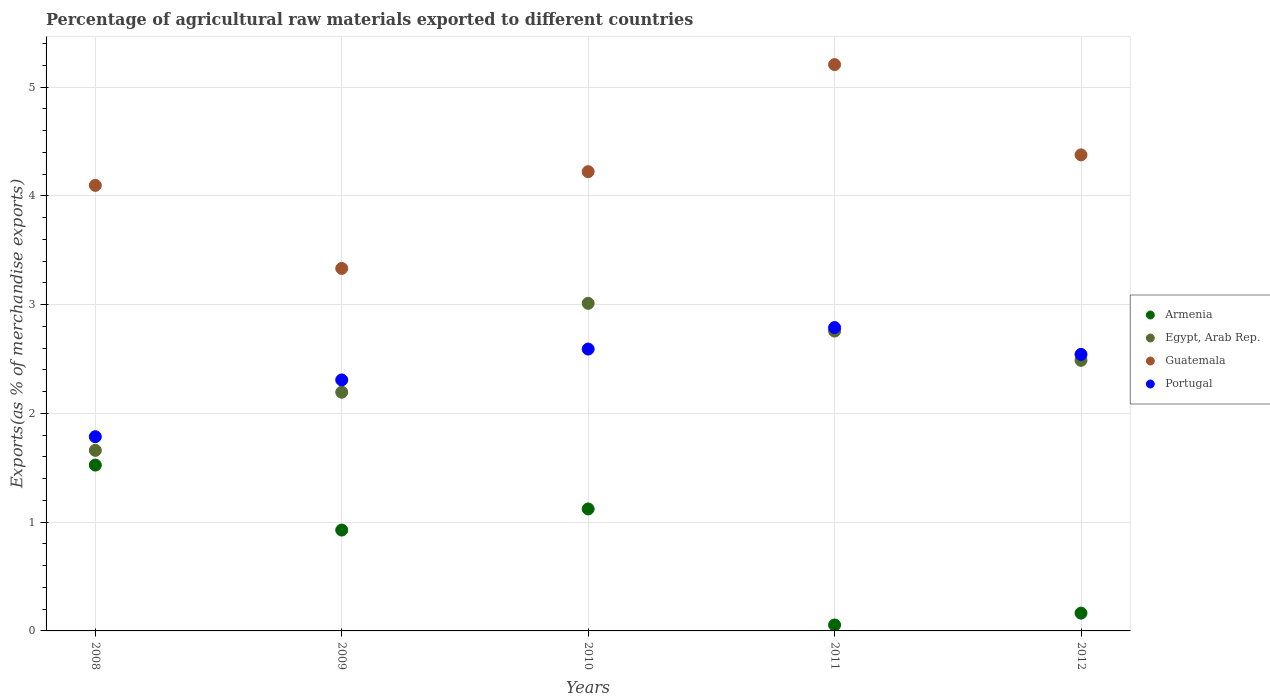Is the number of dotlines equal to the number of legend labels?
Your answer should be compact. Yes. What is the percentage of exports to different countries in Armenia in 2008?
Give a very brief answer. 1.52. Across all years, what is the maximum percentage of exports to different countries in Portugal?
Your answer should be very brief. 2.79. Across all years, what is the minimum percentage of exports to different countries in Egypt, Arab Rep.?
Provide a succinct answer. 1.66. In which year was the percentage of exports to different countries in Egypt, Arab Rep. minimum?
Offer a terse response. 2008. What is the total percentage of exports to different countries in Egypt, Arab Rep. in the graph?
Offer a very short reply. 12.11. What is the difference between the percentage of exports to different countries in Egypt, Arab Rep. in 2008 and that in 2010?
Keep it short and to the point. -1.35. What is the difference between the percentage of exports to different countries in Armenia in 2009 and the percentage of exports to different countries in Guatemala in 2012?
Provide a short and direct response. -3.45. What is the average percentage of exports to different countries in Armenia per year?
Make the answer very short. 0.76. In the year 2008, what is the difference between the percentage of exports to different countries in Armenia and percentage of exports to different countries in Guatemala?
Your answer should be very brief. -2.57. In how many years, is the percentage of exports to different countries in Portugal greater than 1 %?
Ensure brevity in your answer.  5. What is the ratio of the percentage of exports to different countries in Armenia in 2010 to that in 2012?
Your answer should be compact. 6.85. Is the difference between the percentage of exports to different countries in Armenia in 2011 and 2012 greater than the difference between the percentage of exports to different countries in Guatemala in 2011 and 2012?
Provide a succinct answer. No. What is the difference between the highest and the second highest percentage of exports to different countries in Armenia?
Offer a terse response. 0.4. What is the difference between the highest and the lowest percentage of exports to different countries in Egypt, Arab Rep.?
Keep it short and to the point. 1.35. Is it the case that in every year, the sum of the percentage of exports to different countries in Guatemala and percentage of exports to different countries in Egypt, Arab Rep.  is greater than the sum of percentage of exports to different countries in Armenia and percentage of exports to different countries in Portugal?
Ensure brevity in your answer.  No. Does the percentage of exports to different countries in Guatemala monotonically increase over the years?
Provide a succinct answer. No. How many years are there in the graph?
Ensure brevity in your answer.  5. What is the difference between two consecutive major ticks on the Y-axis?
Give a very brief answer. 1. Are the values on the major ticks of Y-axis written in scientific E-notation?
Your response must be concise. No. Where does the legend appear in the graph?
Your answer should be very brief. Center right. What is the title of the graph?
Provide a succinct answer. Percentage of agricultural raw materials exported to different countries. Does "Iran" appear as one of the legend labels in the graph?
Make the answer very short. No. What is the label or title of the Y-axis?
Provide a succinct answer. Exports(as % of merchandise exports). What is the Exports(as % of merchandise exports) of Armenia in 2008?
Keep it short and to the point. 1.52. What is the Exports(as % of merchandise exports) of Egypt, Arab Rep. in 2008?
Ensure brevity in your answer.  1.66. What is the Exports(as % of merchandise exports) in Guatemala in 2008?
Keep it short and to the point. 4.1. What is the Exports(as % of merchandise exports) of Portugal in 2008?
Make the answer very short. 1.79. What is the Exports(as % of merchandise exports) of Armenia in 2009?
Your answer should be very brief. 0.93. What is the Exports(as % of merchandise exports) in Egypt, Arab Rep. in 2009?
Keep it short and to the point. 2.19. What is the Exports(as % of merchandise exports) in Guatemala in 2009?
Offer a terse response. 3.33. What is the Exports(as % of merchandise exports) of Portugal in 2009?
Offer a very short reply. 2.31. What is the Exports(as % of merchandise exports) in Armenia in 2010?
Provide a short and direct response. 1.12. What is the Exports(as % of merchandise exports) in Egypt, Arab Rep. in 2010?
Provide a succinct answer. 3.01. What is the Exports(as % of merchandise exports) of Guatemala in 2010?
Offer a very short reply. 4.22. What is the Exports(as % of merchandise exports) of Portugal in 2010?
Your answer should be very brief. 2.59. What is the Exports(as % of merchandise exports) in Armenia in 2011?
Your response must be concise. 0.05. What is the Exports(as % of merchandise exports) of Egypt, Arab Rep. in 2011?
Your answer should be compact. 2.76. What is the Exports(as % of merchandise exports) of Guatemala in 2011?
Ensure brevity in your answer.  5.21. What is the Exports(as % of merchandise exports) of Portugal in 2011?
Your response must be concise. 2.79. What is the Exports(as % of merchandise exports) in Armenia in 2012?
Your answer should be very brief. 0.16. What is the Exports(as % of merchandise exports) in Egypt, Arab Rep. in 2012?
Keep it short and to the point. 2.49. What is the Exports(as % of merchandise exports) of Guatemala in 2012?
Provide a short and direct response. 4.38. What is the Exports(as % of merchandise exports) in Portugal in 2012?
Your response must be concise. 2.54. Across all years, what is the maximum Exports(as % of merchandise exports) in Armenia?
Offer a terse response. 1.52. Across all years, what is the maximum Exports(as % of merchandise exports) in Egypt, Arab Rep.?
Your answer should be compact. 3.01. Across all years, what is the maximum Exports(as % of merchandise exports) of Guatemala?
Ensure brevity in your answer.  5.21. Across all years, what is the maximum Exports(as % of merchandise exports) of Portugal?
Your answer should be very brief. 2.79. Across all years, what is the minimum Exports(as % of merchandise exports) of Armenia?
Provide a short and direct response. 0.05. Across all years, what is the minimum Exports(as % of merchandise exports) of Egypt, Arab Rep.?
Provide a succinct answer. 1.66. Across all years, what is the minimum Exports(as % of merchandise exports) of Guatemala?
Provide a short and direct response. 3.33. Across all years, what is the minimum Exports(as % of merchandise exports) of Portugal?
Offer a very short reply. 1.79. What is the total Exports(as % of merchandise exports) in Armenia in the graph?
Give a very brief answer. 3.79. What is the total Exports(as % of merchandise exports) of Egypt, Arab Rep. in the graph?
Give a very brief answer. 12.11. What is the total Exports(as % of merchandise exports) of Guatemala in the graph?
Provide a succinct answer. 21.23. What is the total Exports(as % of merchandise exports) in Portugal in the graph?
Provide a short and direct response. 12.02. What is the difference between the Exports(as % of merchandise exports) in Armenia in 2008 and that in 2009?
Provide a short and direct response. 0.6. What is the difference between the Exports(as % of merchandise exports) of Egypt, Arab Rep. in 2008 and that in 2009?
Your answer should be very brief. -0.53. What is the difference between the Exports(as % of merchandise exports) of Guatemala in 2008 and that in 2009?
Provide a succinct answer. 0.76. What is the difference between the Exports(as % of merchandise exports) of Portugal in 2008 and that in 2009?
Provide a short and direct response. -0.52. What is the difference between the Exports(as % of merchandise exports) of Armenia in 2008 and that in 2010?
Give a very brief answer. 0.4. What is the difference between the Exports(as % of merchandise exports) in Egypt, Arab Rep. in 2008 and that in 2010?
Offer a terse response. -1.35. What is the difference between the Exports(as % of merchandise exports) of Guatemala in 2008 and that in 2010?
Make the answer very short. -0.13. What is the difference between the Exports(as % of merchandise exports) of Portugal in 2008 and that in 2010?
Offer a terse response. -0.81. What is the difference between the Exports(as % of merchandise exports) in Armenia in 2008 and that in 2011?
Provide a short and direct response. 1.47. What is the difference between the Exports(as % of merchandise exports) of Egypt, Arab Rep. in 2008 and that in 2011?
Offer a terse response. -1.1. What is the difference between the Exports(as % of merchandise exports) in Guatemala in 2008 and that in 2011?
Provide a short and direct response. -1.11. What is the difference between the Exports(as % of merchandise exports) of Portugal in 2008 and that in 2011?
Your response must be concise. -1. What is the difference between the Exports(as % of merchandise exports) of Armenia in 2008 and that in 2012?
Your response must be concise. 1.36. What is the difference between the Exports(as % of merchandise exports) in Egypt, Arab Rep. in 2008 and that in 2012?
Give a very brief answer. -0.83. What is the difference between the Exports(as % of merchandise exports) of Guatemala in 2008 and that in 2012?
Give a very brief answer. -0.28. What is the difference between the Exports(as % of merchandise exports) of Portugal in 2008 and that in 2012?
Make the answer very short. -0.76. What is the difference between the Exports(as % of merchandise exports) of Armenia in 2009 and that in 2010?
Provide a succinct answer. -0.19. What is the difference between the Exports(as % of merchandise exports) in Egypt, Arab Rep. in 2009 and that in 2010?
Offer a terse response. -0.82. What is the difference between the Exports(as % of merchandise exports) of Guatemala in 2009 and that in 2010?
Provide a short and direct response. -0.89. What is the difference between the Exports(as % of merchandise exports) of Portugal in 2009 and that in 2010?
Offer a terse response. -0.28. What is the difference between the Exports(as % of merchandise exports) in Armenia in 2009 and that in 2011?
Give a very brief answer. 0.87. What is the difference between the Exports(as % of merchandise exports) in Egypt, Arab Rep. in 2009 and that in 2011?
Provide a short and direct response. -0.56. What is the difference between the Exports(as % of merchandise exports) of Guatemala in 2009 and that in 2011?
Your answer should be very brief. -1.87. What is the difference between the Exports(as % of merchandise exports) in Portugal in 2009 and that in 2011?
Provide a short and direct response. -0.48. What is the difference between the Exports(as % of merchandise exports) in Armenia in 2009 and that in 2012?
Your response must be concise. 0.76. What is the difference between the Exports(as % of merchandise exports) in Egypt, Arab Rep. in 2009 and that in 2012?
Your answer should be very brief. -0.29. What is the difference between the Exports(as % of merchandise exports) of Guatemala in 2009 and that in 2012?
Offer a very short reply. -1.04. What is the difference between the Exports(as % of merchandise exports) of Portugal in 2009 and that in 2012?
Make the answer very short. -0.23. What is the difference between the Exports(as % of merchandise exports) of Armenia in 2010 and that in 2011?
Offer a terse response. 1.07. What is the difference between the Exports(as % of merchandise exports) of Egypt, Arab Rep. in 2010 and that in 2011?
Give a very brief answer. 0.26. What is the difference between the Exports(as % of merchandise exports) in Guatemala in 2010 and that in 2011?
Provide a succinct answer. -0.98. What is the difference between the Exports(as % of merchandise exports) of Portugal in 2010 and that in 2011?
Your answer should be very brief. -0.2. What is the difference between the Exports(as % of merchandise exports) of Armenia in 2010 and that in 2012?
Keep it short and to the point. 0.96. What is the difference between the Exports(as % of merchandise exports) of Egypt, Arab Rep. in 2010 and that in 2012?
Your answer should be very brief. 0.52. What is the difference between the Exports(as % of merchandise exports) of Guatemala in 2010 and that in 2012?
Offer a terse response. -0.15. What is the difference between the Exports(as % of merchandise exports) of Portugal in 2010 and that in 2012?
Provide a succinct answer. 0.05. What is the difference between the Exports(as % of merchandise exports) of Armenia in 2011 and that in 2012?
Give a very brief answer. -0.11. What is the difference between the Exports(as % of merchandise exports) of Egypt, Arab Rep. in 2011 and that in 2012?
Offer a terse response. 0.27. What is the difference between the Exports(as % of merchandise exports) in Guatemala in 2011 and that in 2012?
Keep it short and to the point. 0.83. What is the difference between the Exports(as % of merchandise exports) of Portugal in 2011 and that in 2012?
Make the answer very short. 0.25. What is the difference between the Exports(as % of merchandise exports) of Armenia in 2008 and the Exports(as % of merchandise exports) of Egypt, Arab Rep. in 2009?
Your answer should be compact. -0.67. What is the difference between the Exports(as % of merchandise exports) in Armenia in 2008 and the Exports(as % of merchandise exports) in Guatemala in 2009?
Provide a short and direct response. -1.81. What is the difference between the Exports(as % of merchandise exports) of Armenia in 2008 and the Exports(as % of merchandise exports) of Portugal in 2009?
Give a very brief answer. -0.78. What is the difference between the Exports(as % of merchandise exports) of Egypt, Arab Rep. in 2008 and the Exports(as % of merchandise exports) of Guatemala in 2009?
Ensure brevity in your answer.  -1.67. What is the difference between the Exports(as % of merchandise exports) in Egypt, Arab Rep. in 2008 and the Exports(as % of merchandise exports) in Portugal in 2009?
Ensure brevity in your answer.  -0.65. What is the difference between the Exports(as % of merchandise exports) in Guatemala in 2008 and the Exports(as % of merchandise exports) in Portugal in 2009?
Offer a very short reply. 1.79. What is the difference between the Exports(as % of merchandise exports) in Armenia in 2008 and the Exports(as % of merchandise exports) in Egypt, Arab Rep. in 2010?
Give a very brief answer. -1.49. What is the difference between the Exports(as % of merchandise exports) of Armenia in 2008 and the Exports(as % of merchandise exports) of Guatemala in 2010?
Offer a very short reply. -2.7. What is the difference between the Exports(as % of merchandise exports) in Armenia in 2008 and the Exports(as % of merchandise exports) in Portugal in 2010?
Your answer should be very brief. -1.07. What is the difference between the Exports(as % of merchandise exports) of Egypt, Arab Rep. in 2008 and the Exports(as % of merchandise exports) of Guatemala in 2010?
Your answer should be very brief. -2.56. What is the difference between the Exports(as % of merchandise exports) in Egypt, Arab Rep. in 2008 and the Exports(as % of merchandise exports) in Portugal in 2010?
Make the answer very short. -0.93. What is the difference between the Exports(as % of merchandise exports) in Guatemala in 2008 and the Exports(as % of merchandise exports) in Portugal in 2010?
Provide a short and direct response. 1.5. What is the difference between the Exports(as % of merchandise exports) in Armenia in 2008 and the Exports(as % of merchandise exports) in Egypt, Arab Rep. in 2011?
Your answer should be very brief. -1.23. What is the difference between the Exports(as % of merchandise exports) in Armenia in 2008 and the Exports(as % of merchandise exports) in Guatemala in 2011?
Provide a succinct answer. -3.68. What is the difference between the Exports(as % of merchandise exports) in Armenia in 2008 and the Exports(as % of merchandise exports) in Portugal in 2011?
Your answer should be compact. -1.26. What is the difference between the Exports(as % of merchandise exports) of Egypt, Arab Rep. in 2008 and the Exports(as % of merchandise exports) of Guatemala in 2011?
Keep it short and to the point. -3.55. What is the difference between the Exports(as % of merchandise exports) in Egypt, Arab Rep. in 2008 and the Exports(as % of merchandise exports) in Portugal in 2011?
Provide a succinct answer. -1.13. What is the difference between the Exports(as % of merchandise exports) in Guatemala in 2008 and the Exports(as % of merchandise exports) in Portugal in 2011?
Ensure brevity in your answer.  1.31. What is the difference between the Exports(as % of merchandise exports) in Armenia in 2008 and the Exports(as % of merchandise exports) in Egypt, Arab Rep. in 2012?
Ensure brevity in your answer.  -0.96. What is the difference between the Exports(as % of merchandise exports) in Armenia in 2008 and the Exports(as % of merchandise exports) in Guatemala in 2012?
Your answer should be compact. -2.85. What is the difference between the Exports(as % of merchandise exports) in Armenia in 2008 and the Exports(as % of merchandise exports) in Portugal in 2012?
Provide a short and direct response. -1.02. What is the difference between the Exports(as % of merchandise exports) of Egypt, Arab Rep. in 2008 and the Exports(as % of merchandise exports) of Guatemala in 2012?
Your answer should be very brief. -2.72. What is the difference between the Exports(as % of merchandise exports) of Egypt, Arab Rep. in 2008 and the Exports(as % of merchandise exports) of Portugal in 2012?
Make the answer very short. -0.88. What is the difference between the Exports(as % of merchandise exports) of Guatemala in 2008 and the Exports(as % of merchandise exports) of Portugal in 2012?
Make the answer very short. 1.55. What is the difference between the Exports(as % of merchandise exports) of Armenia in 2009 and the Exports(as % of merchandise exports) of Egypt, Arab Rep. in 2010?
Offer a very short reply. -2.08. What is the difference between the Exports(as % of merchandise exports) in Armenia in 2009 and the Exports(as % of merchandise exports) in Guatemala in 2010?
Provide a short and direct response. -3.3. What is the difference between the Exports(as % of merchandise exports) in Armenia in 2009 and the Exports(as % of merchandise exports) in Portugal in 2010?
Offer a very short reply. -1.66. What is the difference between the Exports(as % of merchandise exports) of Egypt, Arab Rep. in 2009 and the Exports(as % of merchandise exports) of Guatemala in 2010?
Your answer should be compact. -2.03. What is the difference between the Exports(as % of merchandise exports) of Egypt, Arab Rep. in 2009 and the Exports(as % of merchandise exports) of Portugal in 2010?
Keep it short and to the point. -0.4. What is the difference between the Exports(as % of merchandise exports) of Guatemala in 2009 and the Exports(as % of merchandise exports) of Portugal in 2010?
Provide a succinct answer. 0.74. What is the difference between the Exports(as % of merchandise exports) of Armenia in 2009 and the Exports(as % of merchandise exports) of Egypt, Arab Rep. in 2011?
Make the answer very short. -1.83. What is the difference between the Exports(as % of merchandise exports) in Armenia in 2009 and the Exports(as % of merchandise exports) in Guatemala in 2011?
Your answer should be very brief. -4.28. What is the difference between the Exports(as % of merchandise exports) of Armenia in 2009 and the Exports(as % of merchandise exports) of Portugal in 2011?
Ensure brevity in your answer.  -1.86. What is the difference between the Exports(as % of merchandise exports) in Egypt, Arab Rep. in 2009 and the Exports(as % of merchandise exports) in Guatemala in 2011?
Your answer should be very brief. -3.01. What is the difference between the Exports(as % of merchandise exports) of Egypt, Arab Rep. in 2009 and the Exports(as % of merchandise exports) of Portugal in 2011?
Your answer should be compact. -0.59. What is the difference between the Exports(as % of merchandise exports) of Guatemala in 2009 and the Exports(as % of merchandise exports) of Portugal in 2011?
Offer a very short reply. 0.54. What is the difference between the Exports(as % of merchandise exports) of Armenia in 2009 and the Exports(as % of merchandise exports) of Egypt, Arab Rep. in 2012?
Offer a very short reply. -1.56. What is the difference between the Exports(as % of merchandise exports) of Armenia in 2009 and the Exports(as % of merchandise exports) of Guatemala in 2012?
Ensure brevity in your answer.  -3.45. What is the difference between the Exports(as % of merchandise exports) in Armenia in 2009 and the Exports(as % of merchandise exports) in Portugal in 2012?
Your answer should be very brief. -1.61. What is the difference between the Exports(as % of merchandise exports) of Egypt, Arab Rep. in 2009 and the Exports(as % of merchandise exports) of Guatemala in 2012?
Ensure brevity in your answer.  -2.18. What is the difference between the Exports(as % of merchandise exports) in Egypt, Arab Rep. in 2009 and the Exports(as % of merchandise exports) in Portugal in 2012?
Keep it short and to the point. -0.35. What is the difference between the Exports(as % of merchandise exports) of Guatemala in 2009 and the Exports(as % of merchandise exports) of Portugal in 2012?
Give a very brief answer. 0.79. What is the difference between the Exports(as % of merchandise exports) in Armenia in 2010 and the Exports(as % of merchandise exports) in Egypt, Arab Rep. in 2011?
Ensure brevity in your answer.  -1.64. What is the difference between the Exports(as % of merchandise exports) of Armenia in 2010 and the Exports(as % of merchandise exports) of Guatemala in 2011?
Ensure brevity in your answer.  -4.09. What is the difference between the Exports(as % of merchandise exports) of Armenia in 2010 and the Exports(as % of merchandise exports) of Portugal in 2011?
Ensure brevity in your answer.  -1.67. What is the difference between the Exports(as % of merchandise exports) in Egypt, Arab Rep. in 2010 and the Exports(as % of merchandise exports) in Guatemala in 2011?
Your response must be concise. -2.19. What is the difference between the Exports(as % of merchandise exports) in Egypt, Arab Rep. in 2010 and the Exports(as % of merchandise exports) in Portugal in 2011?
Provide a succinct answer. 0.22. What is the difference between the Exports(as % of merchandise exports) in Guatemala in 2010 and the Exports(as % of merchandise exports) in Portugal in 2011?
Ensure brevity in your answer.  1.43. What is the difference between the Exports(as % of merchandise exports) of Armenia in 2010 and the Exports(as % of merchandise exports) of Egypt, Arab Rep. in 2012?
Offer a terse response. -1.37. What is the difference between the Exports(as % of merchandise exports) in Armenia in 2010 and the Exports(as % of merchandise exports) in Guatemala in 2012?
Give a very brief answer. -3.26. What is the difference between the Exports(as % of merchandise exports) of Armenia in 2010 and the Exports(as % of merchandise exports) of Portugal in 2012?
Give a very brief answer. -1.42. What is the difference between the Exports(as % of merchandise exports) in Egypt, Arab Rep. in 2010 and the Exports(as % of merchandise exports) in Guatemala in 2012?
Provide a succinct answer. -1.36. What is the difference between the Exports(as % of merchandise exports) in Egypt, Arab Rep. in 2010 and the Exports(as % of merchandise exports) in Portugal in 2012?
Offer a very short reply. 0.47. What is the difference between the Exports(as % of merchandise exports) of Guatemala in 2010 and the Exports(as % of merchandise exports) of Portugal in 2012?
Give a very brief answer. 1.68. What is the difference between the Exports(as % of merchandise exports) of Armenia in 2011 and the Exports(as % of merchandise exports) of Egypt, Arab Rep. in 2012?
Your response must be concise. -2.43. What is the difference between the Exports(as % of merchandise exports) in Armenia in 2011 and the Exports(as % of merchandise exports) in Guatemala in 2012?
Provide a short and direct response. -4.32. What is the difference between the Exports(as % of merchandise exports) in Armenia in 2011 and the Exports(as % of merchandise exports) in Portugal in 2012?
Offer a terse response. -2.49. What is the difference between the Exports(as % of merchandise exports) of Egypt, Arab Rep. in 2011 and the Exports(as % of merchandise exports) of Guatemala in 2012?
Your answer should be compact. -1.62. What is the difference between the Exports(as % of merchandise exports) of Egypt, Arab Rep. in 2011 and the Exports(as % of merchandise exports) of Portugal in 2012?
Give a very brief answer. 0.21. What is the difference between the Exports(as % of merchandise exports) in Guatemala in 2011 and the Exports(as % of merchandise exports) in Portugal in 2012?
Your answer should be very brief. 2.66. What is the average Exports(as % of merchandise exports) in Armenia per year?
Your response must be concise. 0.76. What is the average Exports(as % of merchandise exports) of Egypt, Arab Rep. per year?
Provide a succinct answer. 2.42. What is the average Exports(as % of merchandise exports) in Guatemala per year?
Give a very brief answer. 4.25. What is the average Exports(as % of merchandise exports) of Portugal per year?
Offer a very short reply. 2.4. In the year 2008, what is the difference between the Exports(as % of merchandise exports) of Armenia and Exports(as % of merchandise exports) of Egypt, Arab Rep.?
Provide a short and direct response. -0.14. In the year 2008, what is the difference between the Exports(as % of merchandise exports) of Armenia and Exports(as % of merchandise exports) of Guatemala?
Your response must be concise. -2.57. In the year 2008, what is the difference between the Exports(as % of merchandise exports) of Armenia and Exports(as % of merchandise exports) of Portugal?
Provide a succinct answer. -0.26. In the year 2008, what is the difference between the Exports(as % of merchandise exports) in Egypt, Arab Rep. and Exports(as % of merchandise exports) in Guatemala?
Offer a terse response. -2.44. In the year 2008, what is the difference between the Exports(as % of merchandise exports) in Egypt, Arab Rep. and Exports(as % of merchandise exports) in Portugal?
Provide a short and direct response. -0.13. In the year 2008, what is the difference between the Exports(as % of merchandise exports) in Guatemala and Exports(as % of merchandise exports) in Portugal?
Give a very brief answer. 2.31. In the year 2009, what is the difference between the Exports(as % of merchandise exports) of Armenia and Exports(as % of merchandise exports) of Egypt, Arab Rep.?
Offer a very short reply. -1.27. In the year 2009, what is the difference between the Exports(as % of merchandise exports) in Armenia and Exports(as % of merchandise exports) in Guatemala?
Offer a terse response. -2.41. In the year 2009, what is the difference between the Exports(as % of merchandise exports) of Armenia and Exports(as % of merchandise exports) of Portugal?
Make the answer very short. -1.38. In the year 2009, what is the difference between the Exports(as % of merchandise exports) in Egypt, Arab Rep. and Exports(as % of merchandise exports) in Guatemala?
Your response must be concise. -1.14. In the year 2009, what is the difference between the Exports(as % of merchandise exports) of Egypt, Arab Rep. and Exports(as % of merchandise exports) of Portugal?
Keep it short and to the point. -0.11. In the year 2009, what is the difference between the Exports(as % of merchandise exports) of Guatemala and Exports(as % of merchandise exports) of Portugal?
Ensure brevity in your answer.  1.03. In the year 2010, what is the difference between the Exports(as % of merchandise exports) of Armenia and Exports(as % of merchandise exports) of Egypt, Arab Rep.?
Your answer should be very brief. -1.89. In the year 2010, what is the difference between the Exports(as % of merchandise exports) of Armenia and Exports(as % of merchandise exports) of Guatemala?
Keep it short and to the point. -3.1. In the year 2010, what is the difference between the Exports(as % of merchandise exports) of Armenia and Exports(as % of merchandise exports) of Portugal?
Keep it short and to the point. -1.47. In the year 2010, what is the difference between the Exports(as % of merchandise exports) of Egypt, Arab Rep. and Exports(as % of merchandise exports) of Guatemala?
Give a very brief answer. -1.21. In the year 2010, what is the difference between the Exports(as % of merchandise exports) of Egypt, Arab Rep. and Exports(as % of merchandise exports) of Portugal?
Make the answer very short. 0.42. In the year 2010, what is the difference between the Exports(as % of merchandise exports) in Guatemala and Exports(as % of merchandise exports) in Portugal?
Make the answer very short. 1.63. In the year 2011, what is the difference between the Exports(as % of merchandise exports) in Armenia and Exports(as % of merchandise exports) in Egypt, Arab Rep.?
Your answer should be compact. -2.7. In the year 2011, what is the difference between the Exports(as % of merchandise exports) in Armenia and Exports(as % of merchandise exports) in Guatemala?
Your response must be concise. -5.15. In the year 2011, what is the difference between the Exports(as % of merchandise exports) of Armenia and Exports(as % of merchandise exports) of Portugal?
Ensure brevity in your answer.  -2.73. In the year 2011, what is the difference between the Exports(as % of merchandise exports) in Egypt, Arab Rep. and Exports(as % of merchandise exports) in Guatemala?
Your answer should be compact. -2.45. In the year 2011, what is the difference between the Exports(as % of merchandise exports) of Egypt, Arab Rep. and Exports(as % of merchandise exports) of Portugal?
Your answer should be compact. -0.03. In the year 2011, what is the difference between the Exports(as % of merchandise exports) in Guatemala and Exports(as % of merchandise exports) in Portugal?
Give a very brief answer. 2.42. In the year 2012, what is the difference between the Exports(as % of merchandise exports) of Armenia and Exports(as % of merchandise exports) of Egypt, Arab Rep.?
Your response must be concise. -2.32. In the year 2012, what is the difference between the Exports(as % of merchandise exports) in Armenia and Exports(as % of merchandise exports) in Guatemala?
Your answer should be very brief. -4.21. In the year 2012, what is the difference between the Exports(as % of merchandise exports) in Armenia and Exports(as % of merchandise exports) in Portugal?
Provide a short and direct response. -2.38. In the year 2012, what is the difference between the Exports(as % of merchandise exports) in Egypt, Arab Rep. and Exports(as % of merchandise exports) in Guatemala?
Give a very brief answer. -1.89. In the year 2012, what is the difference between the Exports(as % of merchandise exports) of Egypt, Arab Rep. and Exports(as % of merchandise exports) of Portugal?
Make the answer very short. -0.05. In the year 2012, what is the difference between the Exports(as % of merchandise exports) of Guatemala and Exports(as % of merchandise exports) of Portugal?
Ensure brevity in your answer.  1.83. What is the ratio of the Exports(as % of merchandise exports) of Armenia in 2008 to that in 2009?
Offer a very short reply. 1.64. What is the ratio of the Exports(as % of merchandise exports) in Egypt, Arab Rep. in 2008 to that in 2009?
Offer a very short reply. 0.76. What is the ratio of the Exports(as % of merchandise exports) in Guatemala in 2008 to that in 2009?
Your answer should be compact. 1.23. What is the ratio of the Exports(as % of merchandise exports) of Portugal in 2008 to that in 2009?
Give a very brief answer. 0.77. What is the ratio of the Exports(as % of merchandise exports) of Armenia in 2008 to that in 2010?
Your response must be concise. 1.36. What is the ratio of the Exports(as % of merchandise exports) in Egypt, Arab Rep. in 2008 to that in 2010?
Your answer should be compact. 0.55. What is the ratio of the Exports(as % of merchandise exports) of Guatemala in 2008 to that in 2010?
Your response must be concise. 0.97. What is the ratio of the Exports(as % of merchandise exports) in Portugal in 2008 to that in 2010?
Give a very brief answer. 0.69. What is the ratio of the Exports(as % of merchandise exports) of Armenia in 2008 to that in 2011?
Provide a short and direct response. 27.91. What is the ratio of the Exports(as % of merchandise exports) of Egypt, Arab Rep. in 2008 to that in 2011?
Your answer should be very brief. 0.6. What is the ratio of the Exports(as % of merchandise exports) of Guatemala in 2008 to that in 2011?
Ensure brevity in your answer.  0.79. What is the ratio of the Exports(as % of merchandise exports) of Portugal in 2008 to that in 2011?
Give a very brief answer. 0.64. What is the ratio of the Exports(as % of merchandise exports) of Armenia in 2008 to that in 2012?
Offer a very short reply. 9.31. What is the ratio of the Exports(as % of merchandise exports) of Egypt, Arab Rep. in 2008 to that in 2012?
Your response must be concise. 0.67. What is the ratio of the Exports(as % of merchandise exports) in Guatemala in 2008 to that in 2012?
Offer a terse response. 0.94. What is the ratio of the Exports(as % of merchandise exports) in Portugal in 2008 to that in 2012?
Offer a very short reply. 0.7. What is the ratio of the Exports(as % of merchandise exports) of Armenia in 2009 to that in 2010?
Ensure brevity in your answer.  0.83. What is the ratio of the Exports(as % of merchandise exports) in Egypt, Arab Rep. in 2009 to that in 2010?
Offer a very short reply. 0.73. What is the ratio of the Exports(as % of merchandise exports) in Guatemala in 2009 to that in 2010?
Make the answer very short. 0.79. What is the ratio of the Exports(as % of merchandise exports) of Portugal in 2009 to that in 2010?
Offer a terse response. 0.89. What is the ratio of the Exports(as % of merchandise exports) in Armenia in 2009 to that in 2011?
Ensure brevity in your answer.  16.97. What is the ratio of the Exports(as % of merchandise exports) of Egypt, Arab Rep. in 2009 to that in 2011?
Give a very brief answer. 0.8. What is the ratio of the Exports(as % of merchandise exports) of Guatemala in 2009 to that in 2011?
Offer a very short reply. 0.64. What is the ratio of the Exports(as % of merchandise exports) of Portugal in 2009 to that in 2011?
Ensure brevity in your answer.  0.83. What is the ratio of the Exports(as % of merchandise exports) of Armenia in 2009 to that in 2012?
Keep it short and to the point. 5.66. What is the ratio of the Exports(as % of merchandise exports) in Egypt, Arab Rep. in 2009 to that in 2012?
Your answer should be very brief. 0.88. What is the ratio of the Exports(as % of merchandise exports) in Guatemala in 2009 to that in 2012?
Give a very brief answer. 0.76. What is the ratio of the Exports(as % of merchandise exports) in Portugal in 2009 to that in 2012?
Provide a short and direct response. 0.91. What is the ratio of the Exports(as % of merchandise exports) of Armenia in 2010 to that in 2011?
Provide a short and direct response. 20.53. What is the ratio of the Exports(as % of merchandise exports) in Egypt, Arab Rep. in 2010 to that in 2011?
Offer a terse response. 1.09. What is the ratio of the Exports(as % of merchandise exports) in Guatemala in 2010 to that in 2011?
Your answer should be very brief. 0.81. What is the ratio of the Exports(as % of merchandise exports) of Portugal in 2010 to that in 2011?
Provide a short and direct response. 0.93. What is the ratio of the Exports(as % of merchandise exports) of Armenia in 2010 to that in 2012?
Provide a succinct answer. 6.85. What is the ratio of the Exports(as % of merchandise exports) of Egypt, Arab Rep. in 2010 to that in 2012?
Your response must be concise. 1.21. What is the ratio of the Exports(as % of merchandise exports) of Guatemala in 2010 to that in 2012?
Make the answer very short. 0.96. What is the ratio of the Exports(as % of merchandise exports) of Portugal in 2010 to that in 2012?
Offer a terse response. 1.02. What is the ratio of the Exports(as % of merchandise exports) of Armenia in 2011 to that in 2012?
Make the answer very short. 0.33. What is the ratio of the Exports(as % of merchandise exports) in Egypt, Arab Rep. in 2011 to that in 2012?
Ensure brevity in your answer.  1.11. What is the ratio of the Exports(as % of merchandise exports) of Guatemala in 2011 to that in 2012?
Give a very brief answer. 1.19. What is the ratio of the Exports(as % of merchandise exports) of Portugal in 2011 to that in 2012?
Ensure brevity in your answer.  1.1. What is the difference between the highest and the second highest Exports(as % of merchandise exports) of Armenia?
Your response must be concise. 0.4. What is the difference between the highest and the second highest Exports(as % of merchandise exports) of Egypt, Arab Rep.?
Give a very brief answer. 0.26. What is the difference between the highest and the second highest Exports(as % of merchandise exports) of Guatemala?
Offer a terse response. 0.83. What is the difference between the highest and the second highest Exports(as % of merchandise exports) in Portugal?
Ensure brevity in your answer.  0.2. What is the difference between the highest and the lowest Exports(as % of merchandise exports) of Armenia?
Provide a short and direct response. 1.47. What is the difference between the highest and the lowest Exports(as % of merchandise exports) in Egypt, Arab Rep.?
Make the answer very short. 1.35. What is the difference between the highest and the lowest Exports(as % of merchandise exports) in Guatemala?
Your answer should be compact. 1.87. What is the difference between the highest and the lowest Exports(as % of merchandise exports) of Portugal?
Give a very brief answer. 1. 